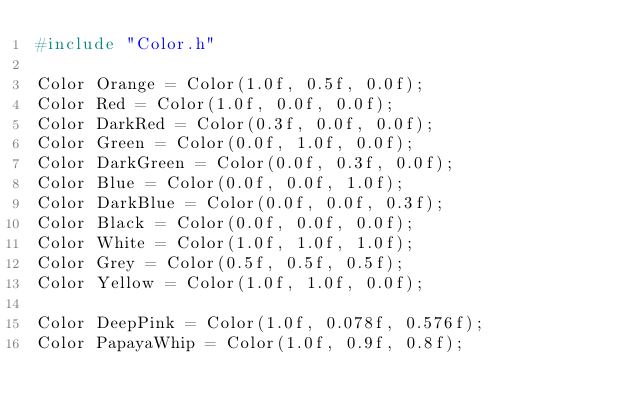<code> <loc_0><loc_0><loc_500><loc_500><_C++_>#include "Color.h"

Color Orange = Color(1.0f, 0.5f, 0.0f);
Color Red = Color(1.0f, 0.0f, 0.0f);
Color DarkRed = Color(0.3f, 0.0f, 0.0f);
Color Green = Color(0.0f, 1.0f, 0.0f);
Color DarkGreen = Color(0.0f, 0.3f, 0.0f);
Color Blue = Color(0.0f, 0.0f, 1.0f);
Color DarkBlue = Color(0.0f, 0.0f, 0.3f);
Color Black = Color(0.0f, 0.0f, 0.0f);
Color White = Color(1.0f, 1.0f, 1.0f);
Color Grey = Color(0.5f, 0.5f, 0.5f);
Color Yellow = Color(1.0f, 1.0f, 0.0f);

Color DeepPink = Color(1.0f, 0.078f, 0.576f);
Color PapayaWhip = Color(1.0f, 0.9f, 0.8f);</code> 